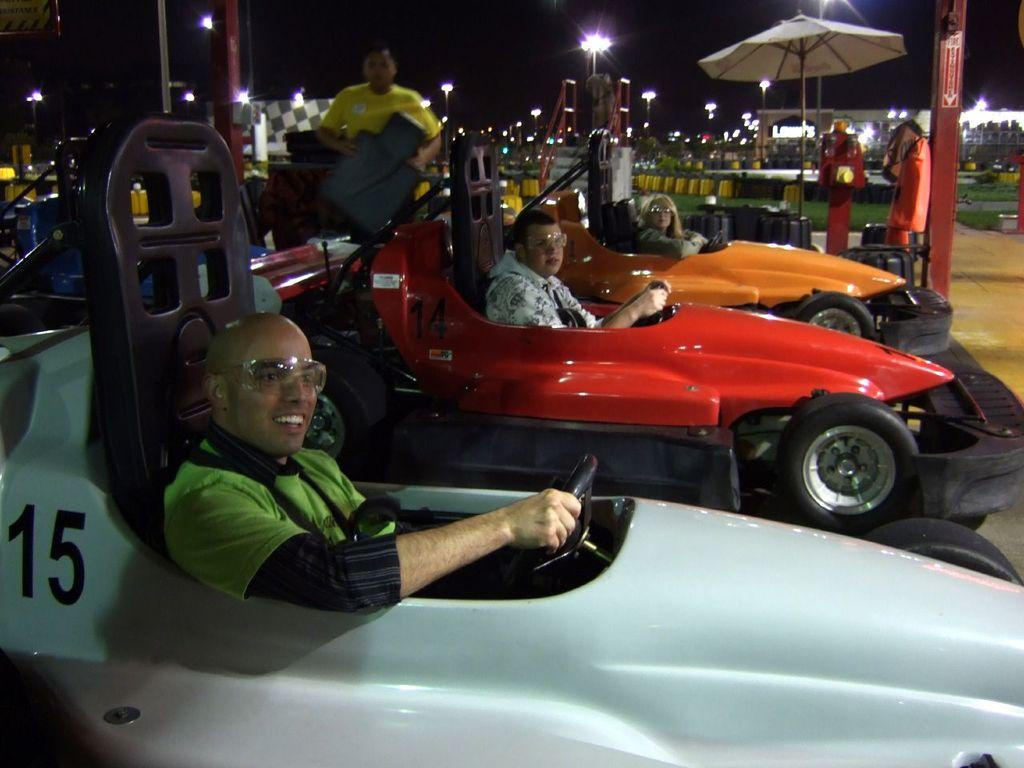What are the people in the image doing? The people in the image are sitting in cars. How can the cars be distinguished from one another? The cars are in different colors. What can be seen in the background of the image? There are lights, tents, stairs, and other objects visible in the background. Can you describe the overall lighting in the image? The image is dark. What type of minister is present in the image? There is no minister present in the image; it features people sitting in cars and various objects in the background. What type of relation does the airplane have to the cars in the image? There is no airplane present in the image, so it cannot have any relation to the cars. 